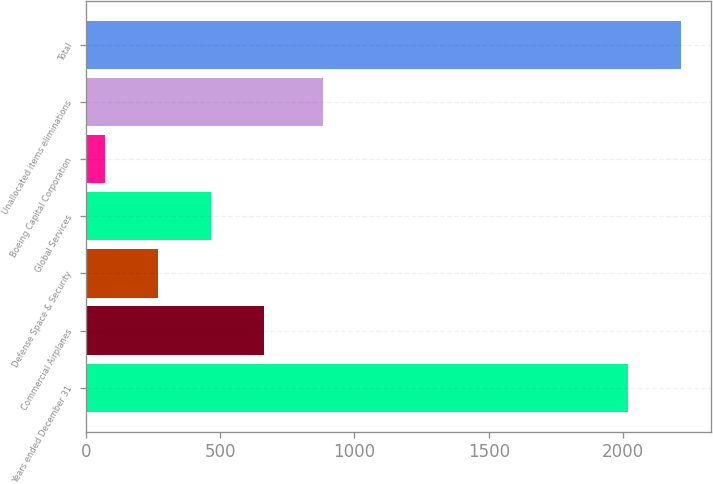Convert chart. <chart><loc_0><loc_0><loc_500><loc_500><bar_chart><fcel>Years ended December 31<fcel>Commercial Airplanes<fcel>Defense Space & Security<fcel>Global Services<fcel>Boeing Capital Corporation<fcel>Unallocated items eliminations<fcel>Total<nl><fcel>2017<fcel>663.1<fcel>267.7<fcel>465.4<fcel>70<fcel>882<fcel>2214.7<nl></chart> 